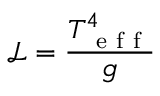<formula> <loc_0><loc_0><loc_500><loc_500>\mathcal { L } = \frac { T _ { e f f } ^ { 4 } } { g }</formula> 